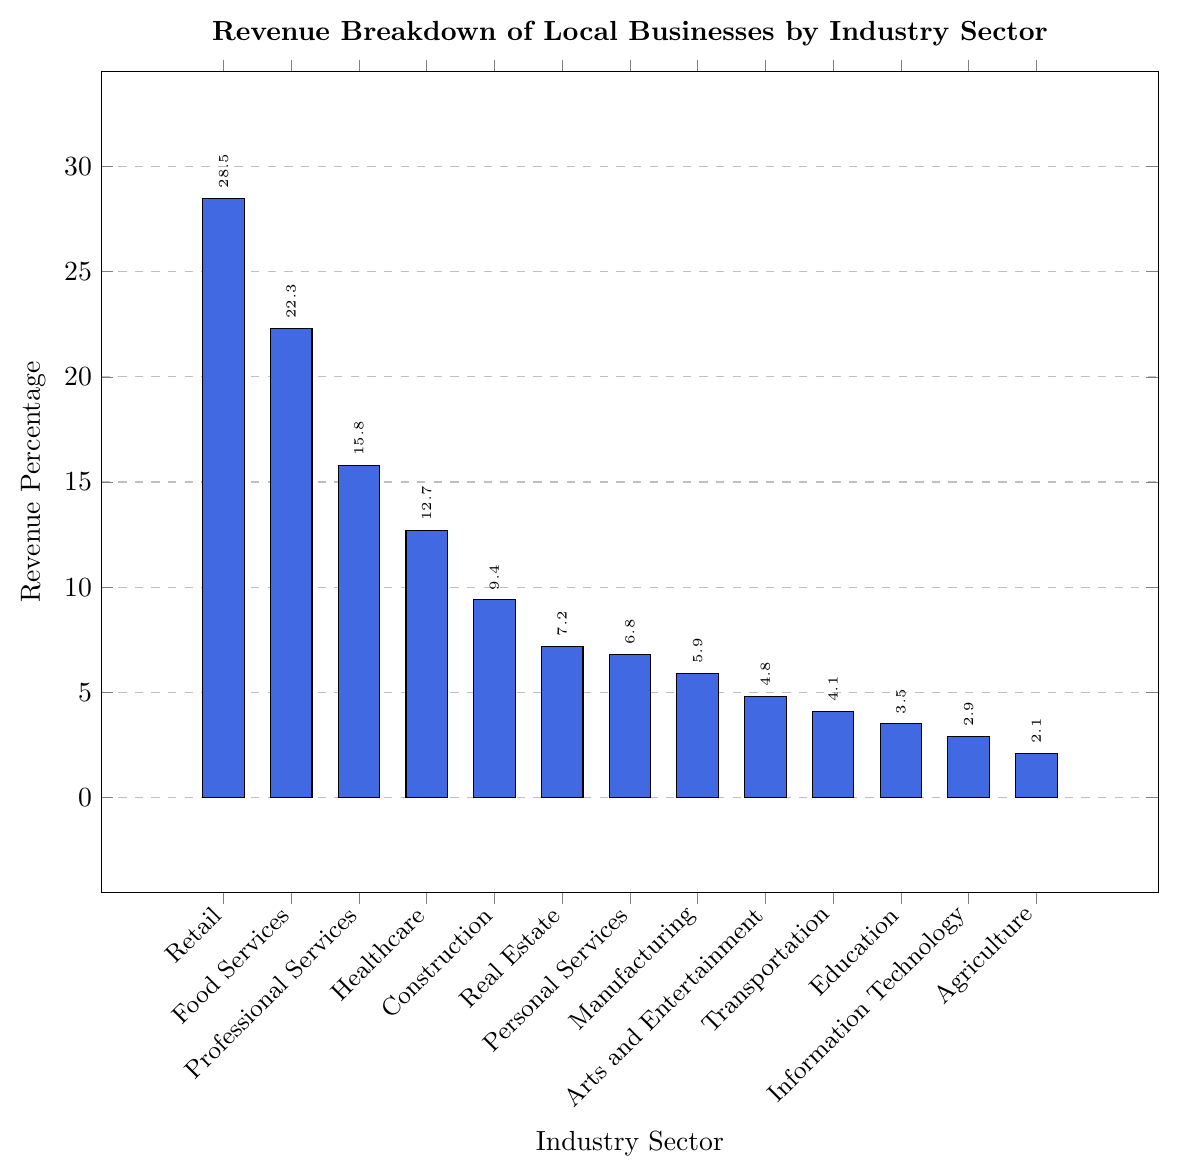What's the percentage of revenue from the Retail sector? Identify the bar labeled "Retail" and read off the value from the y-axis or the label near the bar, which shows 28.5%
Answer: 28.5 Which industry has the lowest revenue percentage? Look for the shortest bar on the chart and check the label, which corresponds to Agriculture with a percentage of 2.1%
Answer: Agriculture How much higher is the revenue percentage of Retail compared to Information Technology? The revenue percentage for Retail is 28.5%, and for Information Technology, it is 2.9%. Subtract to find the difference: 28.5 - 2.9 = 25.6
Answer: 25.6 Which two industries combined contribute around 15% of the revenue? Identify two bars whose summed height is close to 15%. For example, Construction (9.4%) and Real Estate (7.2%) together contribute more than 15%; however, Professional Services (15.8%) almost matches 15% as a single industry. By exploring Individual combinations, "Real Estate”  and "Personal Services” should also hit a very close match, summing up to 14% (7.2% + 6.8%).
Answer: Real Estate and Personal Services Is the Transportation sector's revenue percentage lower than the Arts and Entertainment sector? Compare the heights of the Transportation (4.1%) and Arts and Entertainment (4.8%) bars; Arts and Entertainment, with 4.8%, is higher than Transportation's 4.1%
Answer: Yes What's the total revenue percentage of the top three industry sectors? Add the revenue percentages of the top three sectors: Retail (28.5%) + Food Services (22.3%) + Professional Services (15.8%) = 66.6
Answer: 66.6 Which industry has a revenue percentage closest to 10%? Find the bar where the value is nearest to 10%; Construction at 9.4% is closest
Answer: Construction How many industries have a revenue percentage greater than 10%? Count the bars with values above 10%: Retail (28.5%), Food Services (22.3%), Professional Services (15.8%), and Healthcare (12.7%)— four industries in total
Answer: 4 Compare the combined revenue percentages of Healthcare and Transportation with that of Retail. Which is higher, and by how much? Healthcare (12.7%) + Transportation (4.1%) = 16.8%. Retail alone is 28.5%. The difference is 28.5 - 16.8 = 11.7, so Retail is higher by 11.7
Answer: Retail by 11.7 What's the average revenue percentage for all industries? Sum up all the percentages and divide by the number of industries: (28.5 + 22.3 + 15.8 + 12.7 + 9.4 + 7.2 + 6.8 + 5.9 + 4.8 + 4.1 + 3.5 + 2.9 + 2.1) / 13 = 9.14 (rounded to two decimal places)
Answer: 9.14 